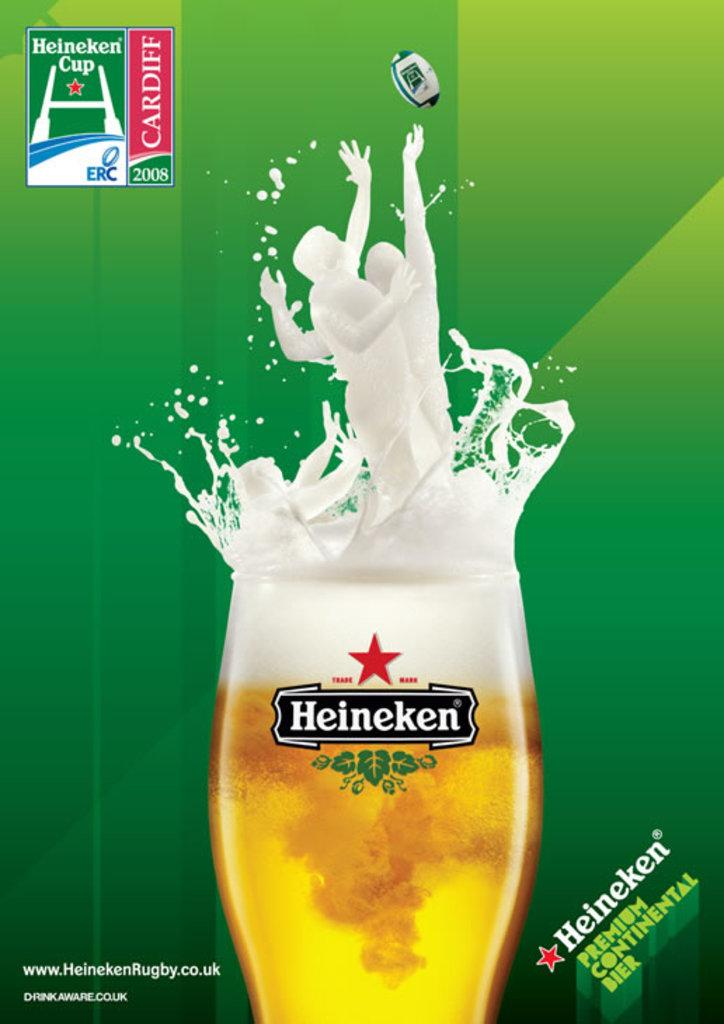<image>
Create a compact narrative representing the image presented. Heineken is the official beer sponsor of the 2008 Cardiff rugby competition. 